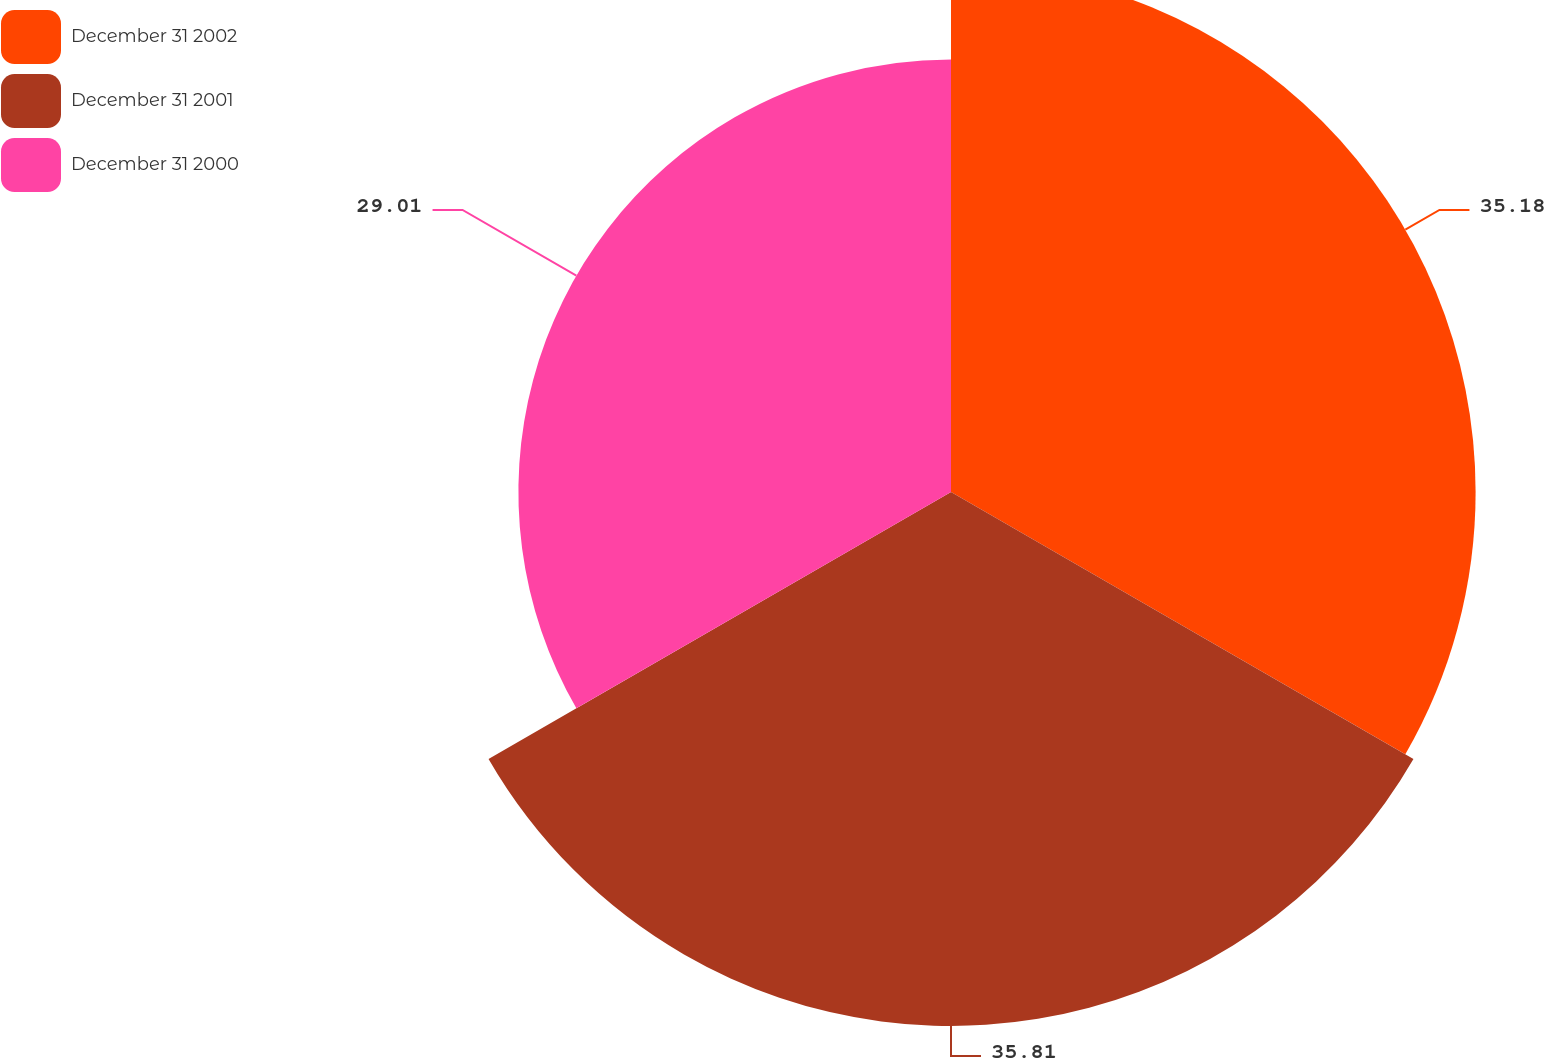Convert chart. <chart><loc_0><loc_0><loc_500><loc_500><pie_chart><fcel>December 31 2002<fcel>December 31 2001<fcel>December 31 2000<nl><fcel>35.18%<fcel>35.81%<fcel>29.01%<nl></chart> 